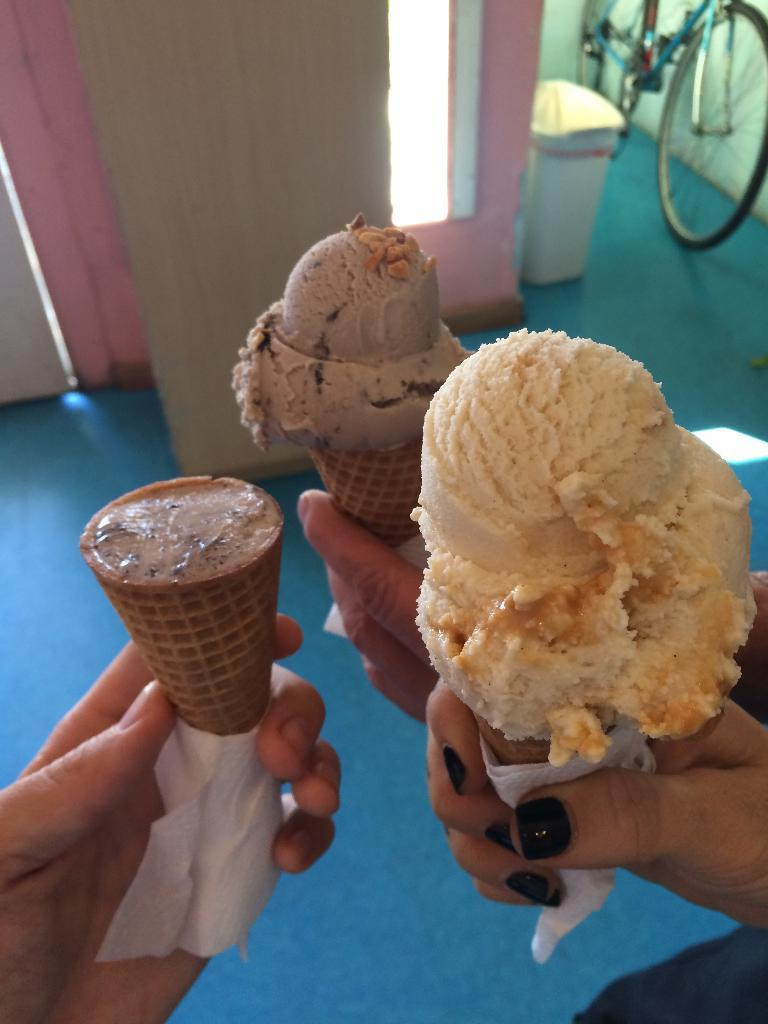What is being held by the hands in the image? There are hands holding ice cream in the image. Can you describe anything else visible in the image? Yes, there is a bicycle visible in the top right side corner of the image. What type of tin can be seen in the image? There is no tin present in the image. How does the unit affect the visibility in the image? There is no unit mentioned in the image, so it cannot affect the visibility. 